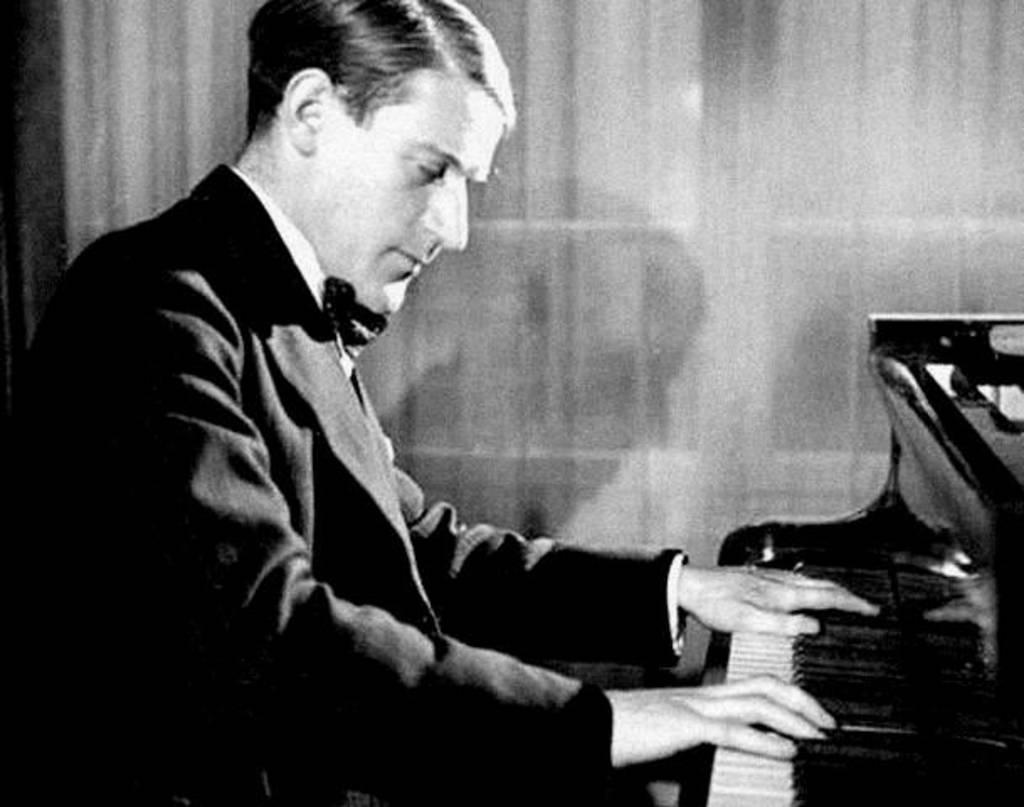What is the setting of the image? The image is inside a room. Who is present in the image? There is a man in the image. What is the man doing in the image? The man is sitting on a chair. What object is in front of the man? The man is in front of a musical keyboard. What is the value of the hammer in the image? There is no hammer present in the image, so it is not possible to determine its value. 